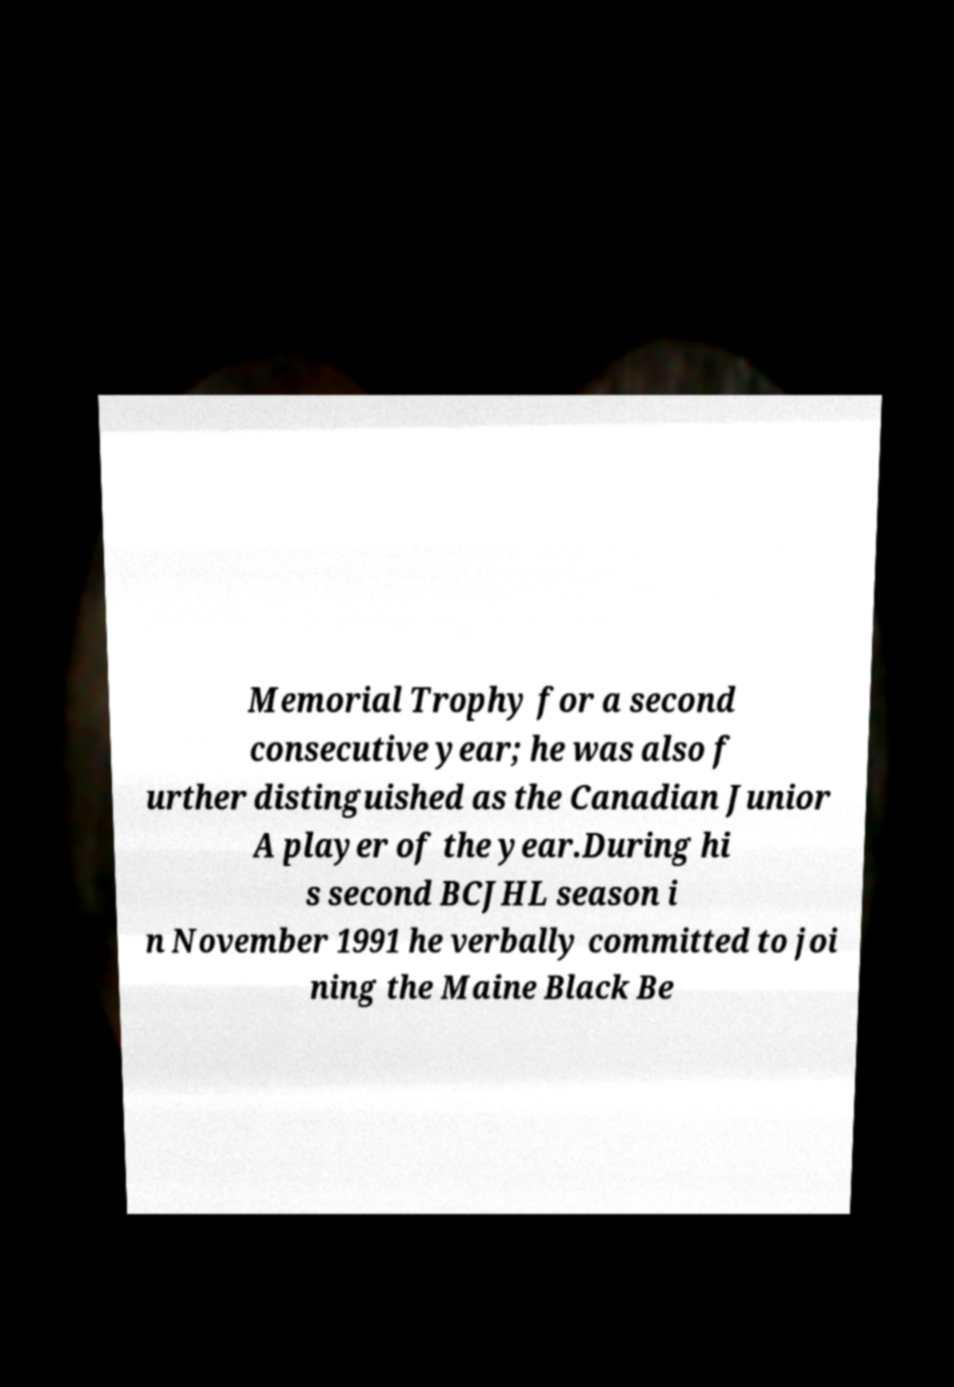There's text embedded in this image that I need extracted. Can you transcribe it verbatim? Memorial Trophy for a second consecutive year; he was also f urther distinguished as the Canadian Junior A player of the year.During hi s second BCJHL season i n November 1991 he verbally committed to joi ning the Maine Black Be 